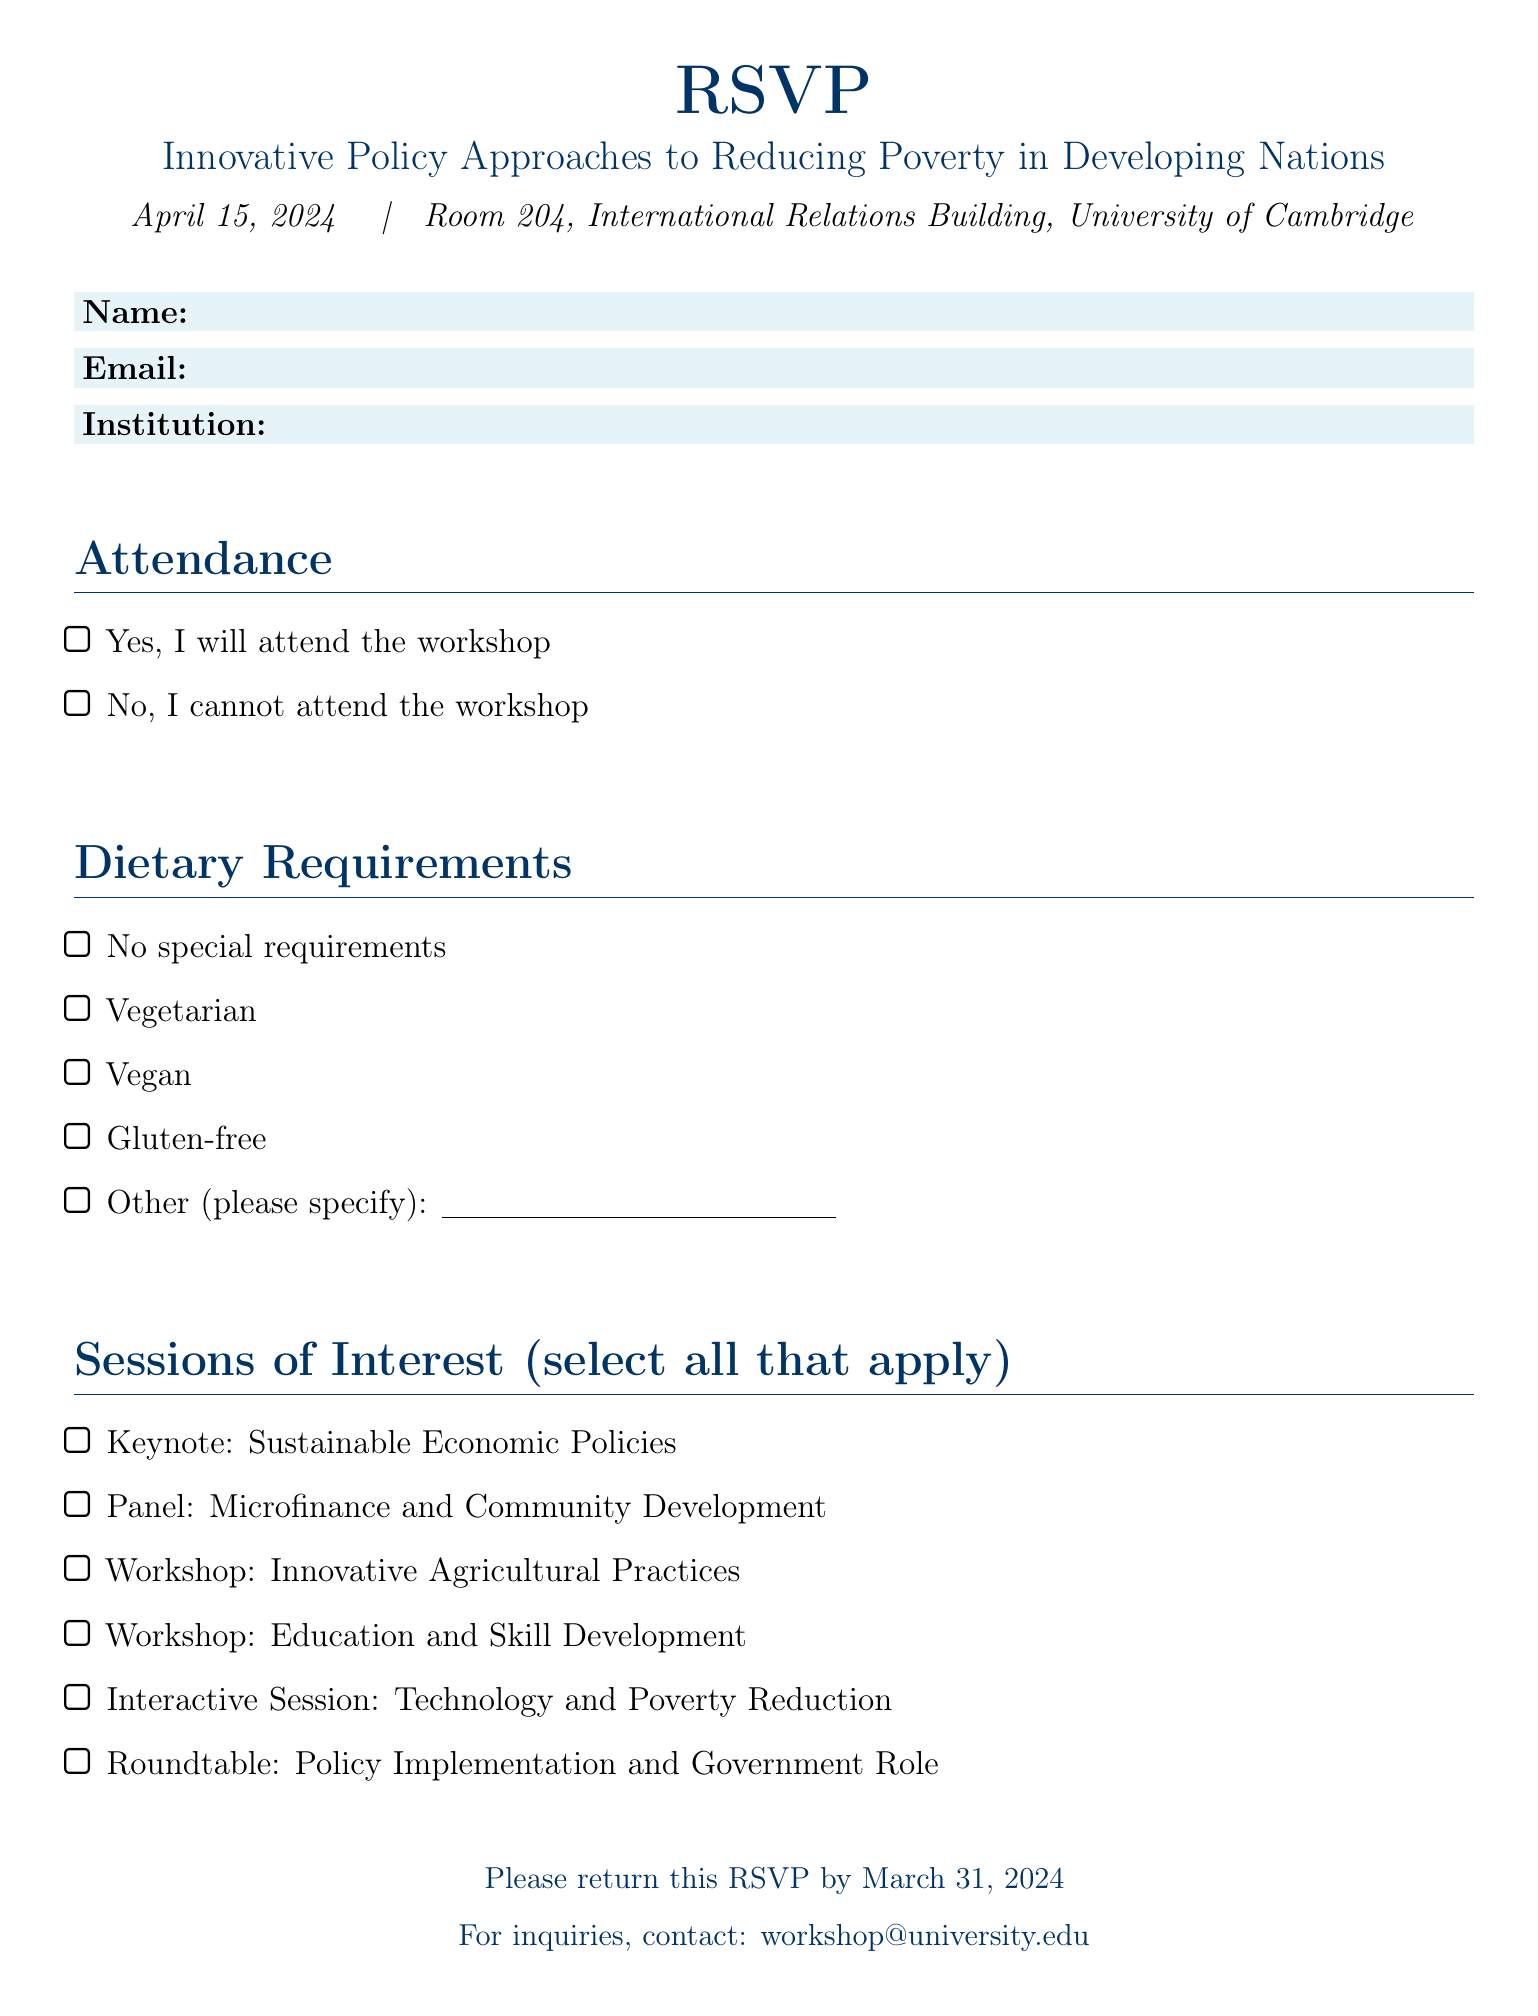What is the date of the workshop? The date of the workshop is specified in the document title and is April 15, 2024.
Answer: April 15, 2024 Where will the workshop take place? The location of the workshop is indicated in the document as Room 204, International Relations Building, University of Cambridge.
Answer: Room 204, International Relations Building, University of Cambridge What is the theme of the workshop? The theme of the workshop is mentioned in the title as Innovative Policy Approaches to Reducing Poverty in Developing Nations.
Answer: Innovative Policy Approaches to Reducing Poverty in Developing Nations When is the RSVP deadline? The RSVP deadline is explicitly stated in the document as March 31, 2024.
Answer: March 31, 2024 What is one of the keynote topics listed? The document lists various sessions, and the keynote topic includes Sustainable Economic Policies.
Answer: Sustainable Economic Policies Are dietary requirements included in the RSVP? The document includes a section on dietary requirements that attendees can specify.
Answer: Yes How many sessions can participants select from? The document enumerates 6 different sessions of interest for the participants to choose from.
Answer: Six Can I select more than one session of interest? The format of the session selection allows for multiple choices, indicating participants can select all that apply.
Answer: Yes What should attendees do if they have inquiries? Attendees are directed to contact a specific email address for inquiries mentioned in the document.
Answer: workshop@university.edu Who is responsible for this workshop? The document does not specify individuals but puts forth an institutional context.
Answer: University of Cambridge 